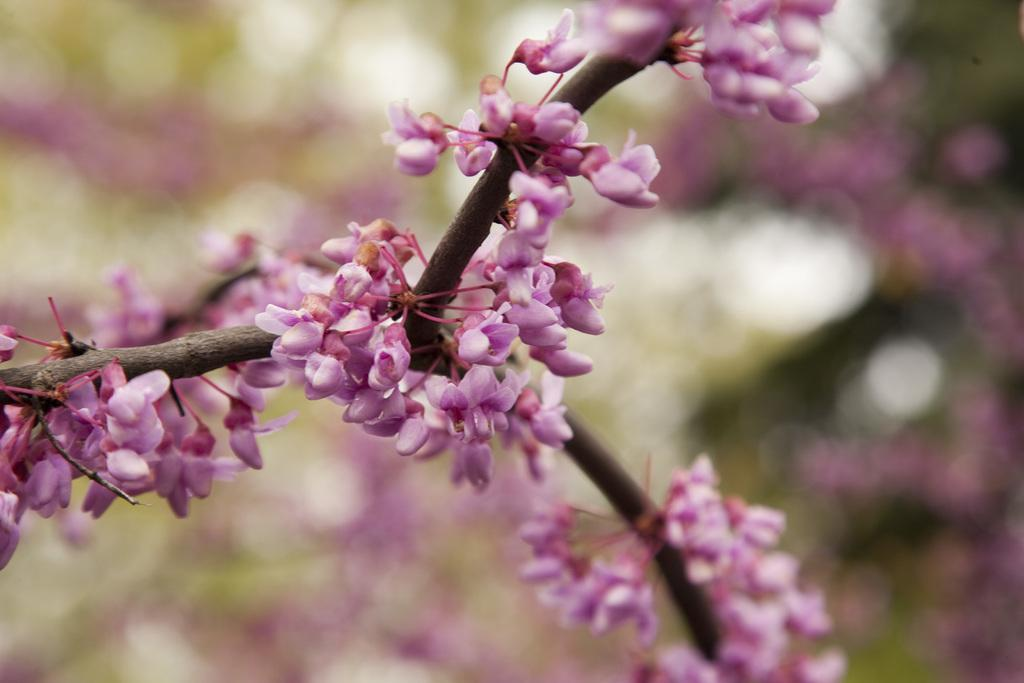What type of plants are in the image? There are flowers in the image. What color are the flowers? The flowers are purple. Can you describe the background of the image? The background of the image is blurred. Do the flowers have wings in the image? No, the flowers do not have wings in the image. What type of respect can be seen in the image? There is no reference to respect in the image; it features flowers and a blurred background. 